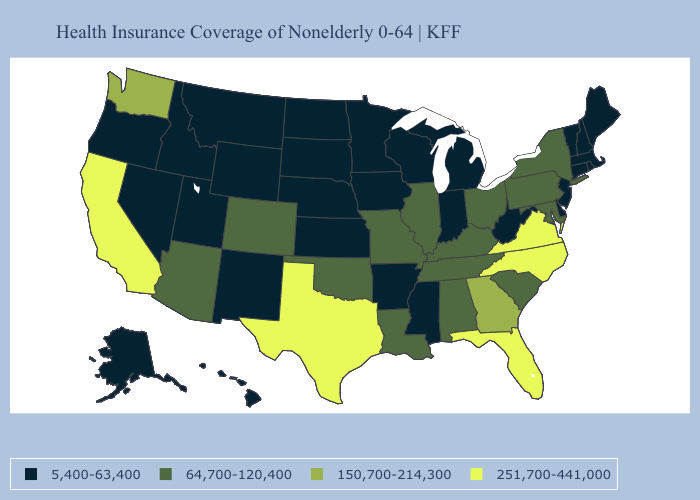What is the value of Oklahoma?
Short answer required. 64,700-120,400. Name the states that have a value in the range 251,700-441,000?
Concise answer only. California, Florida, North Carolina, Texas, Virginia. What is the value of New Jersey?
Quick response, please. 5,400-63,400. Name the states that have a value in the range 5,400-63,400?
Write a very short answer. Alaska, Arkansas, Connecticut, Delaware, Hawaii, Idaho, Indiana, Iowa, Kansas, Maine, Massachusetts, Michigan, Minnesota, Mississippi, Montana, Nebraska, Nevada, New Hampshire, New Jersey, New Mexico, North Dakota, Oregon, Rhode Island, South Dakota, Utah, Vermont, West Virginia, Wisconsin, Wyoming. What is the value of Massachusetts?
Write a very short answer. 5,400-63,400. Which states have the lowest value in the West?
Keep it brief. Alaska, Hawaii, Idaho, Montana, Nevada, New Mexico, Oregon, Utah, Wyoming. Does Hawaii have the highest value in the USA?
Give a very brief answer. No. What is the value of Nebraska?
Keep it brief. 5,400-63,400. Does the first symbol in the legend represent the smallest category?
Keep it brief. Yes. Name the states that have a value in the range 5,400-63,400?
Short answer required. Alaska, Arkansas, Connecticut, Delaware, Hawaii, Idaho, Indiana, Iowa, Kansas, Maine, Massachusetts, Michigan, Minnesota, Mississippi, Montana, Nebraska, Nevada, New Hampshire, New Jersey, New Mexico, North Dakota, Oregon, Rhode Island, South Dakota, Utah, Vermont, West Virginia, Wisconsin, Wyoming. What is the lowest value in the South?
Concise answer only. 5,400-63,400. Which states have the highest value in the USA?
Be succinct. California, Florida, North Carolina, Texas, Virginia. Does the map have missing data?
Be succinct. No. What is the value of Georgia?
Keep it brief. 150,700-214,300. Among the states that border Wisconsin , which have the lowest value?
Answer briefly. Iowa, Michigan, Minnesota. 